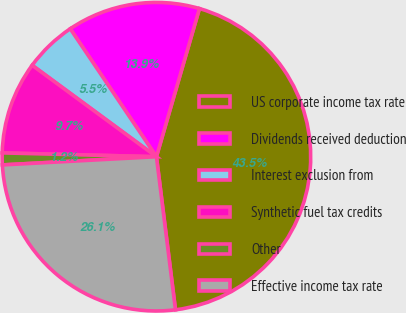<chart> <loc_0><loc_0><loc_500><loc_500><pie_chart><fcel>US corporate income tax rate<fcel>Dividends received deduction<fcel>Interest exclusion from<fcel>Synthetic fuel tax credits<fcel>Other<fcel>Effective income tax rate<nl><fcel>43.53%<fcel>13.93%<fcel>5.47%<fcel>9.7%<fcel>1.24%<fcel>26.12%<nl></chart> 